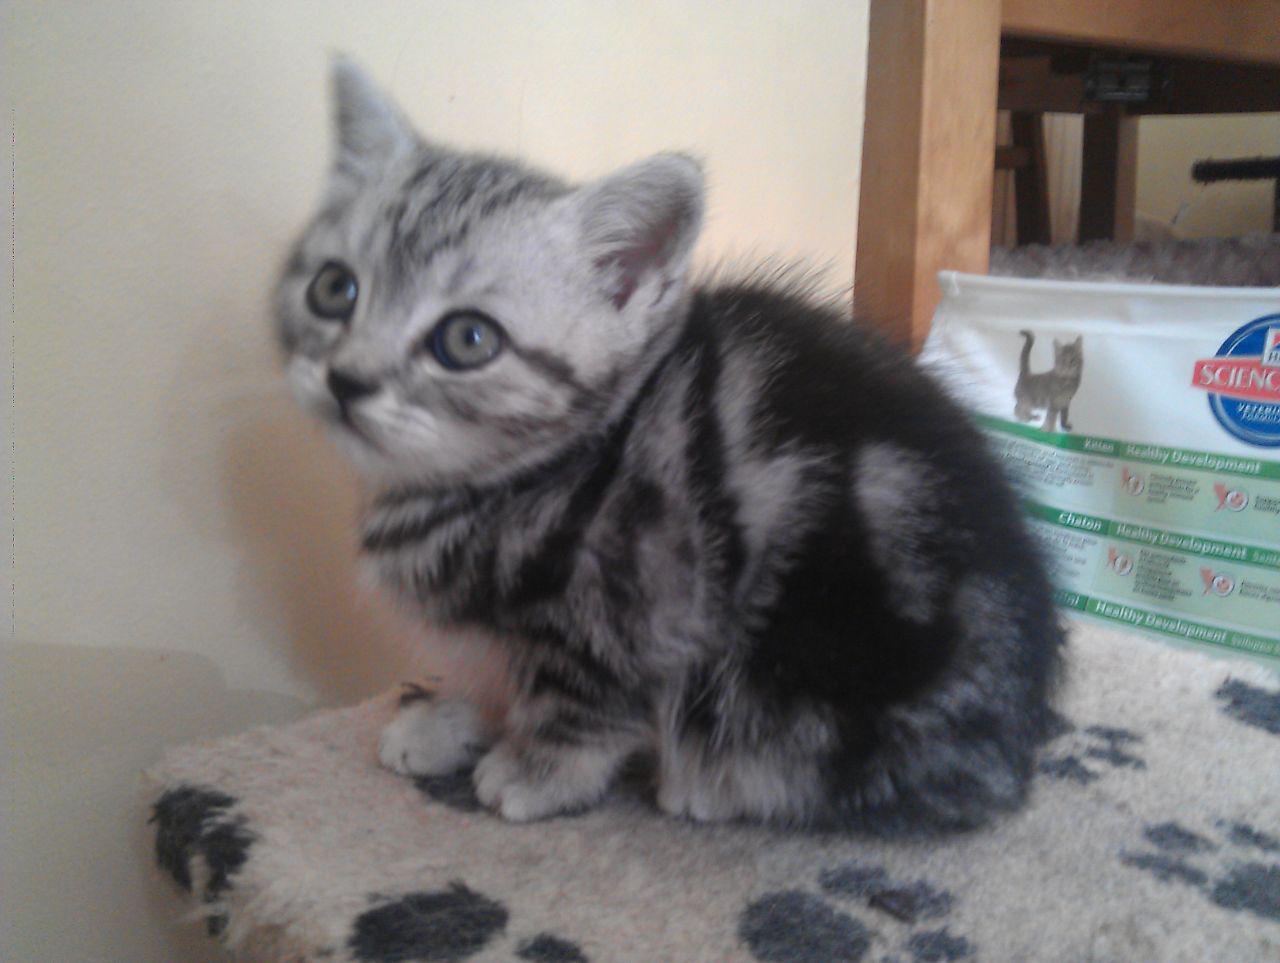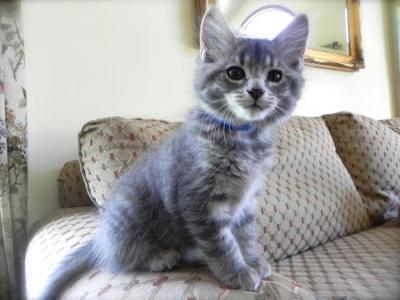The first image is the image on the left, the second image is the image on the right. For the images displayed, is the sentence "The left image shows a cat with open eyes reclining on soft furniture with pillows." factually correct? Answer yes or no. No. The first image is the image on the left, the second image is the image on the right. Given the left and right images, does the statement "The left and right image contains the same number of kittens." hold true? Answer yes or no. Yes. 